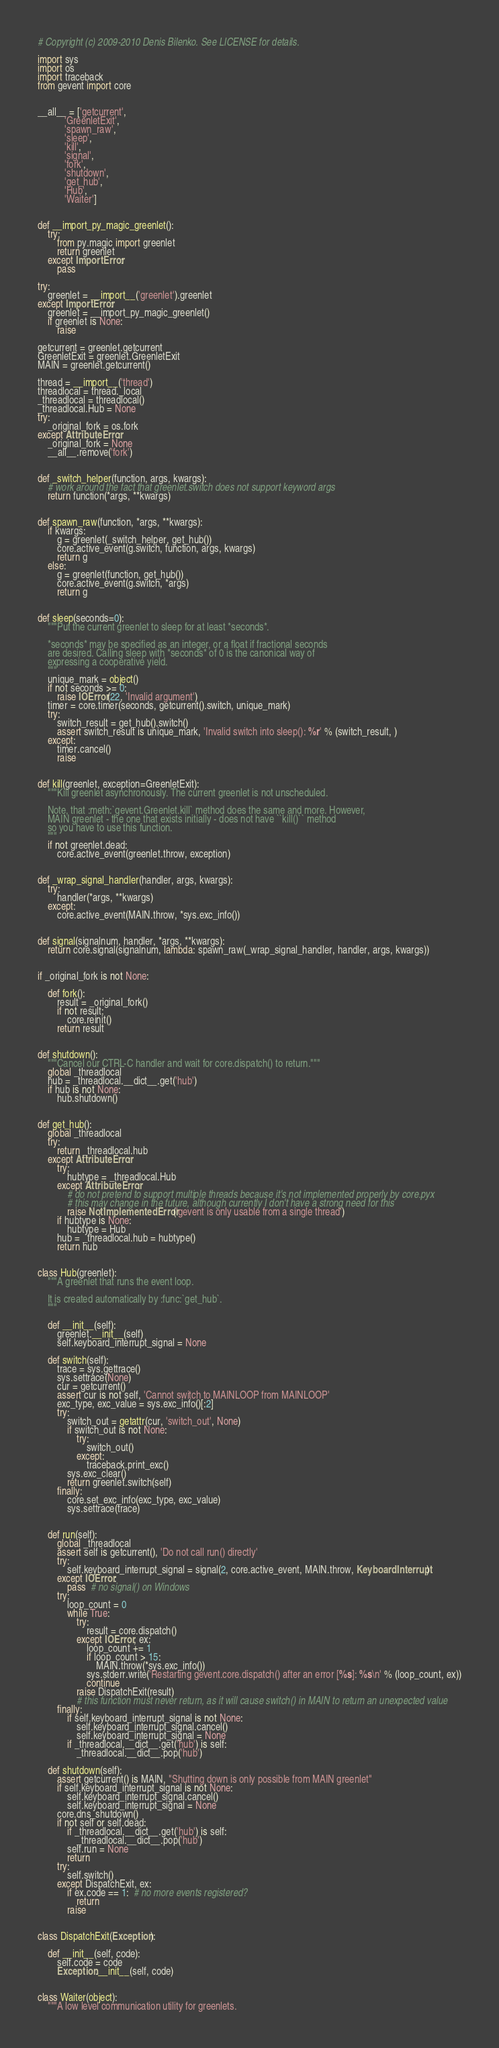<code> <loc_0><loc_0><loc_500><loc_500><_Python_># Copyright (c) 2009-2010 Denis Bilenko. See LICENSE for details.

import sys
import os
import traceback
from gevent import core


__all__ = ['getcurrent',
           'GreenletExit',
           'spawn_raw',
           'sleep',
           'kill',
           'signal',
           'fork',
           'shutdown',
           'get_hub',
           'Hub',
           'Waiter']


def __import_py_magic_greenlet():
    try:
        from py.magic import greenlet
        return greenlet
    except ImportError:
        pass

try:
    greenlet = __import__('greenlet').greenlet
except ImportError:
    greenlet = __import_py_magic_greenlet()
    if greenlet is None:
        raise

getcurrent = greenlet.getcurrent
GreenletExit = greenlet.GreenletExit
MAIN = greenlet.getcurrent()

thread = __import__('thread')
threadlocal = thread._local
_threadlocal = threadlocal()
_threadlocal.Hub = None
try:
    _original_fork = os.fork
except AttributeError:
    _original_fork = None
    __all__.remove('fork')


def _switch_helper(function, args, kwargs):
    # work around the fact that greenlet.switch does not support keyword args
    return function(*args, **kwargs)


def spawn_raw(function, *args, **kwargs):
    if kwargs:
        g = greenlet(_switch_helper, get_hub())
        core.active_event(g.switch, function, args, kwargs)
        return g
    else:
        g = greenlet(function, get_hub())
        core.active_event(g.switch, *args)
        return g


def sleep(seconds=0):
    """Put the current greenlet to sleep for at least *seconds*.

    *seconds* may be specified as an integer, or a float if fractional seconds
    are desired. Calling sleep with *seconds* of 0 is the canonical way of
    expressing a cooperative yield.
    """
    unique_mark = object()
    if not seconds >= 0:
        raise IOError(22, 'Invalid argument')
    timer = core.timer(seconds, getcurrent().switch, unique_mark)
    try:
        switch_result = get_hub().switch()
        assert switch_result is unique_mark, 'Invalid switch into sleep(): %r' % (switch_result, )
    except:
        timer.cancel()
        raise


def kill(greenlet, exception=GreenletExit):
    """Kill greenlet asynchronously. The current greenlet is not unscheduled.

    Note, that :meth:`gevent.Greenlet.kill` method does the same and more. However,
    MAIN greenlet - the one that exists initially - does not have ``kill()`` method
    so you have to use this function.
    """
    if not greenlet.dead:
        core.active_event(greenlet.throw, exception)


def _wrap_signal_handler(handler, args, kwargs):
    try:
        handler(*args, **kwargs)
    except:
        core.active_event(MAIN.throw, *sys.exc_info())


def signal(signalnum, handler, *args, **kwargs):
    return core.signal(signalnum, lambda: spawn_raw(_wrap_signal_handler, handler, args, kwargs))


if _original_fork is not None:

    def fork():
        result = _original_fork()
        if not result:
            core.reinit()
        return result


def shutdown():
    """Cancel our CTRL-C handler and wait for core.dispatch() to return."""
    global _threadlocal
    hub = _threadlocal.__dict__.get('hub')
    if hub is not None:
        hub.shutdown()


def get_hub():
    global _threadlocal
    try:
        return _threadlocal.hub
    except AttributeError:
        try:
            hubtype = _threadlocal.Hub
        except AttributeError:
            # do not pretend to support multiple threads because it's not implemented properly by core.pyx
            # this may change in the future, although currently I don't have a strong need for this
            raise NotImplementedError('gevent is only usable from a single thread')
        if hubtype is None:
            hubtype = Hub
        hub = _threadlocal.hub = hubtype()
        return hub


class Hub(greenlet):
    """A greenlet that runs the event loop.

    It is created automatically by :func:`get_hub`.
    """

    def __init__(self):
        greenlet.__init__(self)
        self.keyboard_interrupt_signal = None

    def switch(self):
        trace = sys.gettrace()
        sys.settrace(None)
        cur = getcurrent()
        assert cur is not self, 'Cannot switch to MAINLOOP from MAINLOOP'
        exc_type, exc_value = sys.exc_info()[:2]
        try:
            switch_out = getattr(cur, 'switch_out', None)
            if switch_out is not None:
                try:
                    switch_out()
                except:
                    traceback.print_exc()
            sys.exc_clear()
            return greenlet.switch(self)
        finally:
            core.set_exc_info(exc_type, exc_value)
            sys.settrace(trace)


    def run(self):
        global _threadlocal
        assert self is getcurrent(), 'Do not call run() directly'
        try:
            self.keyboard_interrupt_signal = signal(2, core.active_event, MAIN.throw, KeyboardInterrupt)
        except IOError:
            pass  # no signal() on Windows
        try:
            loop_count = 0
            while True:
                try:
                    result = core.dispatch()
                except IOError, ex:
                    loop_count += 1
                    if loop_count > 15:
                        MAIN.throw(*sys.exc_info())
                    sys.stderr.write('Restarting gevent.core.dispatch() after an error [%s]: %s\n' % (loop_count, ex))
                    continue
                raise DispatchExit(result)
                # this function must never return, as it will cause switch() in MAIN to return an unexpected value
        finally:
            if self.keyboard_interrupt_signal is not None:
                self.keyboard_interrupt_signal.cancel()
                self.keyboard_interrupt_signal = None
            if _threadlocal.__dict__.get('hub') is self:
                _threadlocal.__dict__.pop('hub')

    def shutdown(self):
        assert getcurrent() is MAIN, "Shutting down is only possible from MAIN greenlet"
        if self.keyboard_interrupt_signal is not None:
            self.keyboard_interrupt_signal.cancel()
            self.keyboard_interrupt_signal = None
        core.dns_shutdown()
        if not self or self.dead:
            if _threadlocal.__dict__.get('hub') is self:
                _threadlocal.__dict__.pop('hub')
            self.run = None
            return
        try:
            self.switch()
        except DispatchExit, ex:
            if ex.code == 1:  # no more events registered?
                return
            raise


class DispatchExit(Exception):

    def __init__(self, code):
        self.code = code
        Exception.__init__(self, code)


class Waiter(object):
    """A low level communication utility for greenlets.
</code> 